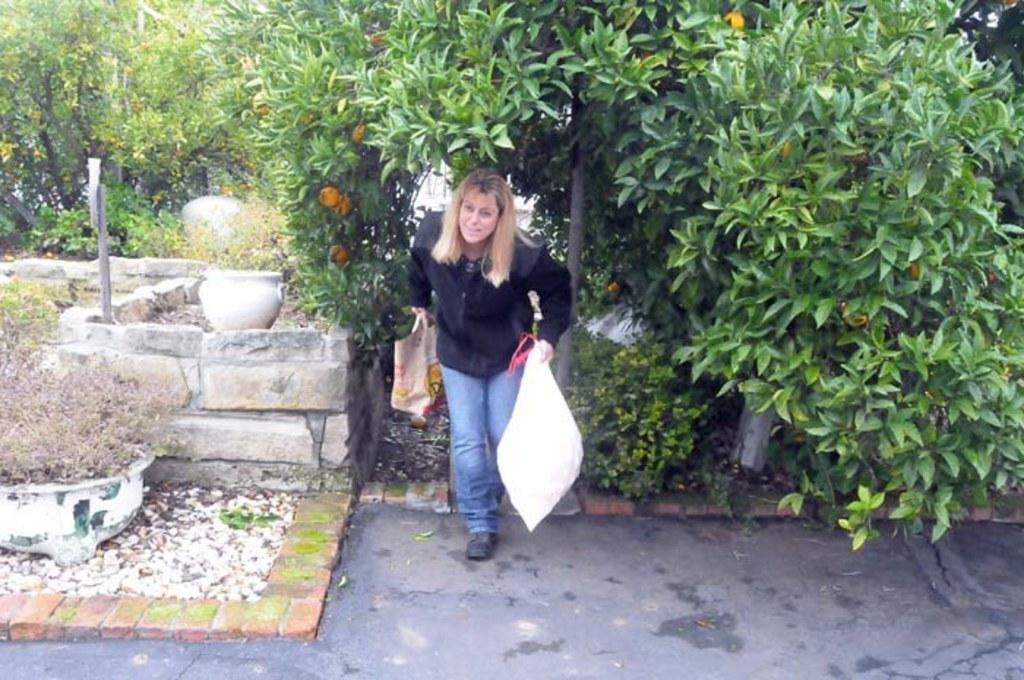Who is the main subject in the image? There is a woman in the image. What is the woman wearing? The woman is wearing a black dress. What is the woman holding in her hands? The woman is holding carry bags in her hands. What can be seen in the background of the image? There are trees visible in the background of the image. What type of army is present in the image? There is no army present in the image; it features a woman holding carry bags and trees in the background. What market is the woman shopping at in the image? There is no indication of a market in the image; the woman is simply holding carry bags. 